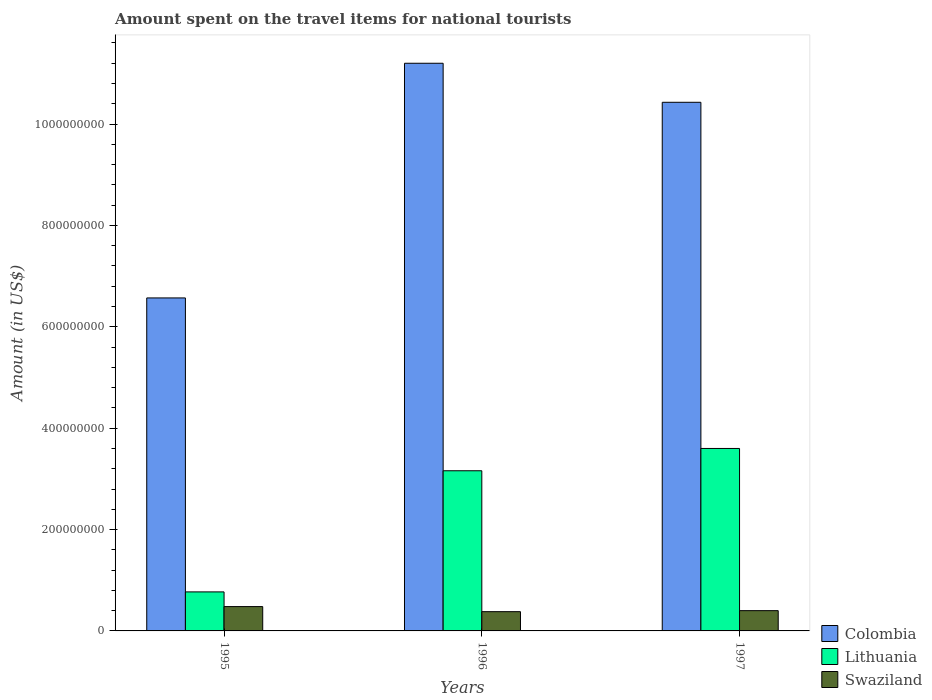How many groups of bars are there?
Your response must be concise. 3. How many bars are there on the 3rd tick from the left?
Provide a short and direct response. 3. How many bars are there on the 3rd tick from the right?
Your response must be concise. 3. What is the label of the 3rd group of bars from the left?
Provide a short and direct response. 1997. In how many cases, is the number of bars for a given year not equal to the number of legend labels?
Keep it short and to the point. 0. What is the amount spent on the travel items for national tourists in Swaziland in 1997?
Your answer should be very brief. 4.00e+07. Across all years, what is the maximum amount spent on the travel items for national tourists in Swaziland?
Your answer should be very brief. 4.80e+07. Across all years, what is the minimum amount spent on the travel items for national tourists in Lithuania?
Make the answer very short. 7.70e+07. In which year was the amount spent on the travel items for national tourists in Colombia maximum?
Offer a very short reply. 1996. What is the total amount spent on the travel items for national tourists in Lithuania in the graph?
Make the answer very short. 7.53e+08. What is the difference between the amount spent on the travel items for national tourists in Colombia in 1996 and that in 1997?
Offer a very short reply. 7.70e+07. What is the difference between the amount spent on the travel items for national tourists in Swaziland in 1997 and the amount spent on the travel items for national tourists in Lithuania in 1996?
Give a very brief answer. -2.76e+08. What is the average amount spent on the travel items for national tourists in Colombia per year?
Provide a succinct answer. 9.40e+08. In the year 1995, what is the difference between the amount spent on the travel items for national tourists in Lithuania and amount spent on the travel items for national tourists in Colombia?
Give a very brief answer. -5.80e+08. In how many years, is the amount spent on the travel items for national tourists in Colombia greater than 280000000 US$?
Provide a succinct answer. 3. Is the difference between the amount spent on the travel items for national tourists in Lithuania in 1995 and 1997 greater than the difference between the amount spent on the travel items for national tourists in Colombia in 1995 and 1997?
Give a very brief answer. Yes. What is the difference between the highest and the second highest amount spent on the travel items for national tourists in Lithuania?
Offer a very short reply. 4.40e+07. What is the difference between the highest and the lowest amount spent on the travel items for national tourists in Colombia?
Offer a terse response. 4.63e+08. In how many years, is the amount spent on the travel items for national tourists in Colombia greater than the average amount spent on the travel items for national tourists in Colombia taken over all years?
Provide a succinct answer. 2. What does the 1st bar from the left in 1996 represents?
Keep it short and to the point. Colombia. What does the 3rd bar from the right in 1996 represents?
Your response must be concise. Colombia. How many bars are there?
Provide a succinct answer. 9. How many years are there in the graph?
Provide a short and direct response. 3. Are the values on the major ticks of Y-axis written in scientific E-notation?
Keep it short and to the point. No. Does the graph contain any zero values?
Offer a terse response. No. Where does the legend appear in the graph?
Offer a very short reply. Bottom right. How are the legend labels stacked?
Your answer should be compact. Vertical. What is the title of the graph?
Keep it short and to the point. Amount spent on the travel items for national tourists. What is the label or title of the Y-axis?
Ensure brevity in your answer.  Amount (in US$). What is the Amount (in US$) in Colombia in 1995?
Offer a very short reply. 6.57e+08. What is the Amount (in US$) in Lithuania in 1995?
Your answer should be compact. 7.70e+07. What is the Amount (in US$) in Swaziland in 1995?
Offer a very short reply. 4.80e+07. What is the Amount (in US$) of Colombia in 1996?
Your response must be concise. 1.12e+09. What is the Amount (in US$) of Lithuania in 1996?
Offer a terse response. 3.16e+08. What is the Amount (in US$) of Swaziland in 1996?
Keep it short and to the point. 3.80e+07. What is the Amount (in US$) of Colombia in 1997?
Offer a very short reply. 1.04e+09. What is the Amount (in US$) in Lithuania in 1997?
Provide a short and direct response. 3.60e+08. What is the Amount (in US$) in Swaziland in 1997?
Keep it short and to the point. 4.00e+07. Across all years, what is the maximum Amount (in US$) in Colombia?
Your response must be concise. 1.12e+09. Across all years, what is the maximum Amount (in US$) of Lithuania?
Offer a terse response. 3.60e+08. Across all years, what is the maximum Amount (in US$) in Swaziland?
Your answer should be compact. 4.80e+07. Across all years, what is the minimum Amount (in US$) of Colombia?
Offer a very short reply. 6.57e+08. Across all years, what is the minimum Amount (in US$) in Lithuania?
Provide a succinct answer. 7.70e+07. Across all years, what is the minimum Amount (in US$) of Swaziland?
Provide a short and direct response. 3.80e+07. What is the total Amount (in US$) in Colombia in the graph?
Provide a short and direct response. 2.82e+09. What is the total Amount (in US$) of Lithuania in the graph?
Your response must be concise. 7.53e+08. What is the total Amount (in US$) of Swaziland in the graph?
Provide a short and direct response. 1.26e+08. What is the difference between the Amount (in US$) in Colombia in 1995 and that in 1996?
Your response must be concise. -4.63e+08. What is the difference between the Amount (in US$) in Lithuania in 1995 and that in 1996?
Provide a succinct answer. -2.39e+08. What is the difference between the Amount (in US$) of Swaziland in 1995 and that in 1996?
Give a very brief answer. 1.00e+07. What is the difference between the Amount (in US$) in Colombia in 1995 and that in 1997?
Your response must be concise. -3.86e+08. What is the difference between the Amount (in US$) of Lithuania in 1995 and that in 1997?
Offer a terse response. -2.83e+08. What is the difference between the Amount (in US$) of Swaziland in 1995 and that in 1997?
Your response must be concise. 8.00e+06. What is the difference between the Amount (in US$) of Colombia in 1996 and that in 1997?
Your response must be concise. 7.70e+07. What is the difference between the Amount (in US$) in Lithuania in 1996 and that in 1997?
Your answer should be very brief. -4.40e+07. What is the difference between the Amount (in US$) in Colombia in 1995 and the Amount (in US$) in Lithuania in 1996?
Your answer should be compact. 3.41e+08. What is the difference between the Amount (in US$) of Colombia in 1995 and the Amount (in US$) of Swaziland in 1996?
Your response must be concise. 6.19e+08. What is the difference between the Amount (in US$) of Lithuania in 1995 and the Amount (in US$) of Swaziland in 1996?
Give a very brief answer. 3.90e+07. What is the difference between the Amount (in US$) of Colombia in 1995 and the Amount (in US$) of Lithuania in 1997?
Offer a very short reply. 2.97e+08. What is the difference between the Amount (in US$) in Colombia in 1995 and the Amount (in US$) in Swaziland in 1997?
Provide a short and direct response. 6.17e+08. What is the difference between the Amount (in US$) of Lithuania in 1995 and the Amount (in US$) of Swaziland in 1997?
Keep it short and to the point. 3.70e+07. What is the difference between the Amount (in US$) of Colombia in 1996 and the Amount (in US$) of Lithuania in 1997?
Your answer should be compact. 7.60e+08. What is the difference between the Amount (in US$) in Colombia in 1996 and the Amount (in US$) in Swaziland in 1997?
Provide a short and direct response. 1.08e+09. What is the difference between the Amount (in US$) in Lithuania in 1996 and the Amount (in US$) in Swaziland in 1997?
Give a very brief answer. 2.76e+08. What is the average Amount (in US$) in Colombia per year?
Give a very brief answer. 9.40e+08. What is the average Amount (in US$) of Lithuania per year?
Provide a short and direct response. 2.51e+08. What is the average Amount (in US$) of Swaziland per year?
Give a very brief answer. 4.20e+07. In the year 1995, what is the difference between the Amount (in US$) of Colombia and Amount (in US$) of Lithuania?
Keep it short and to the point. 5.80e+08. In the year 1995, what is the difference between the Amount (in US$) of Colombia and Amount (in US$) of Swaziland?
Give a very brief answer. 6.09e+08. In the year 1995, what is the difference between the Amount (in US$) in Lithuania and Amount (in US$) in Swaziland?
Provide a succinct answer. 2.90e+07. In the year 1996, what is the difference between the Amount (in US$) in Colombia and Amount (in US$) in Lithuania?
Your response must be concise. 8.04e+08. In the year 1996, what is the difference between the Amount (in US$) of Colombia and Amount (in US$) of Swaziland?
Give a very brief answer. 1.08e+09. In the year 1996, what is the difference between the Amount (in US$) of Lithuania and Amount (in US$) of Swaziland?
Offer a terse response. 2.78e+08. In the year 1997, what is the difference between the Amount (in US$) in Colombia and Amount (in US$) in Lithuania?
Make the answer very short. 6.83e+08. In the year 1997, what is the difference between the Amount (in US$) of Colombia and Amount (in US$) of Swaziland?
Your answer should be compact. 1.00e+09. In the year 1997, what is the difference between the Amount (in US$) of Lithuania and Amount (in US$) of Swaziland?
Your response must be concise. 3.20e+08. What is the ratio of the Amount (in US$) in Colombia in 1995 to that in 1996?
Your answer should be compact. 0.59. What is the ratio of the Amount (in US$) of Lithuania in 1995 to that in 1996?
Offer a terse response. 0.24. What is the ratio of the Amount (in US$) of Swaziland in 1995 to that in 1996?
Keep it short and to the point. 1.26. What is the ratio of the Amount (in US$) in Colombia in 1995 to that in 1997?
Offer a terse response. 0.63. What is the ratio of the Amount (in US$) in Lithuania in 1995 to that in 1997?
Your response must be concise. 0.21. What is the ratio of the Amount (in US$) in Colombia in 1996 to that in 1997?
Ensure brevity in your answer.  1.07. What is the ratio of the Amount (in US$) in Lithuania in 1996 to that in 1997?
Your answer should be compact. 0.88. What is the ratio of the Amount (in US$) in Swaziland in 1996 to that in 1997?
Offer a very short reply. 0.95. What is the difference between the highest and the second highest Amount (in US$) in Colombia?
Provide a short and direct response. 7.70e+07. What is the difference between the highest and the second highest Amount (in US$) of Lithuania?
Your answer should be very brief. 4.40e+07. What is the difference between the highest and the lowest Amount (in US$) of Colombia?
Your answer should be compact. 4.63e+08. What is the difference between the highest and the lowest Amount (in US$) of Lithuania?
Your answer should be very brief. 2.83e+08. What is the difference between the highest and the lowest Amount (in US$) of Swaziland?
Ensure brevity in your answer.  1.00e+07. 